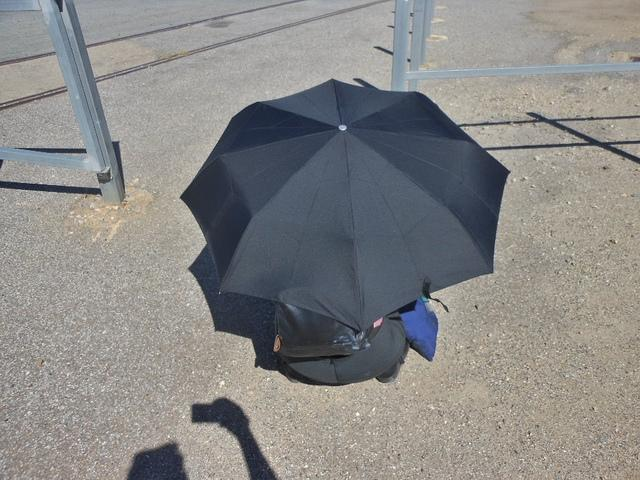Why does the photographer cast a shadow? sun 